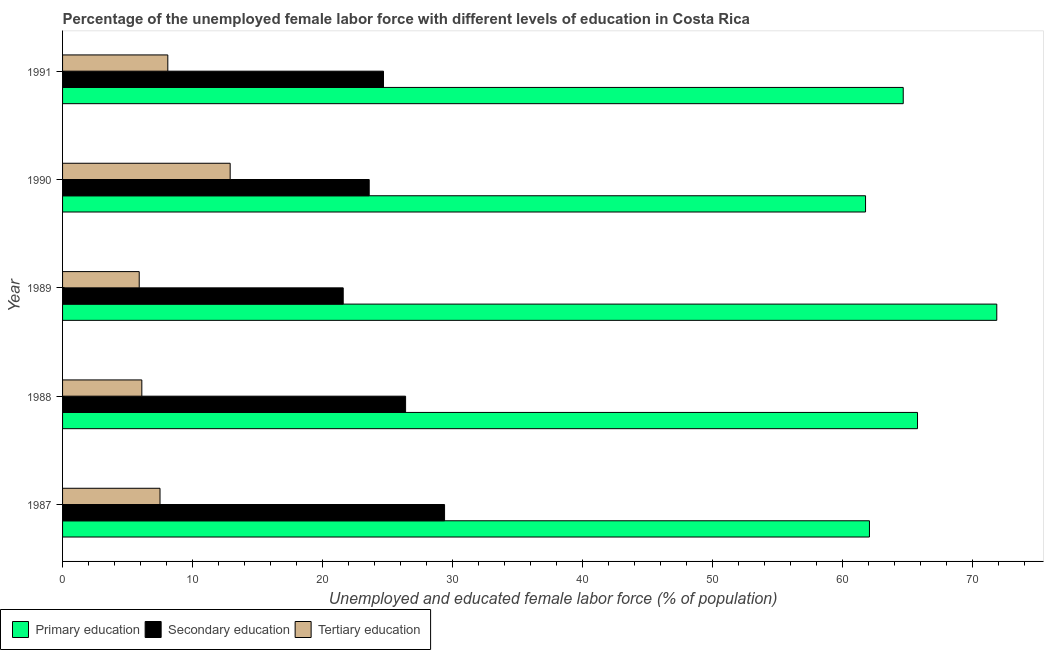Are the number of bars on each tick of the Y-axis equal?
Offer a very short reply. Yes. How many bars are there on the 2nd tick from the top?
Offer a terse response. 3. What is the percentage of female labor force who received tertiary education in 1989?
Provide a short and direct response. 5.9. Across all years, what is the maximum percentage of female labor force who received secondary education?
Your answer should be compact. 29.4. Across all years, what is the minimum percentage of female labor force who received primary education?
Your answer should be very brief. 61.8. In which year was the percentage of female labor force who received secondary education minimum?
Offer a very short reply. 1989. What is the total percentage of female labor force who received primary education in the graph?
Offer a very short reply. 326.3. What is the difference between the percentage of female labor force who received secondary education in 1988 and the percentage of female labor force who received tertiary education in 1990?
Give a very brief answer. 13.5. What is the average percentage of female labor force who received secondary education per year?
Your answer should be very brief. 25.14. In the year 1990, what is the difference between the percentage of female labor force who received primary education and percentage of female labor force who received secondary education?
Give a very brief answer. 38.2. In how many years, is the percentage of female labor force who received tertiary education greater than 66 %?
Your response must be concise. 0. Is the difference between the percentage of female labor force who received primary education in 1990 and 1991 greater than the difference between the percentage of female labor force who received tertiary education in 1990 and 1991?
Provide a short and direct response. No. What is the difference between the highest and the second highest percentage of female labor force who received primary education?
Your answer should be compact. 6.1. In how many years, is the percentage of female labor force who received secondary education greater than the average percentage of female labor force who received secondary education taken over all years?
Your answer should be compact. 2. What does the 1st bar from the top in 1989 represents?
Provide a succinct answer. Tertiary education. What does the 2nd bar from the bottom in 1991 represents?
Keep it short and to the point. Secondary education. Is it the case that in every year, the sum of the percentage of female labor force who received primary education and percentage of female labor force who received secondary education is greater than the percentage of female labor force who received tertiary education?
Keep it short and to the point. Yes. How many bars are there?
Ensure brevity in your answer.  15. What is the difference between two consecutive major ticks on the X-axis?
Make the answer very short. 10. Does the graph contain any zero values?
Keep it short and to the point. No. Does the graph contain grids?
Keep it short and to the point. No. How many legend labels are there?
Give a very brief answer. 3. What is the title of the graph?
Keep it short and to the point. Percentage of the unemployed female labor force with different levels of education in Costa Rica. Does "Methane" appear as one of the legend labels in the graph?
Provide a succinct answer. No. What is the label or title of the X-axis?
Ensure brevity in your answer.  Unemployed and educated female labor force (% of population). What is the label or title of the Y-axis?
Provide a short and direct response. Year. What is the Unemployed and educated female labor force (% of population) of Primary education in 1987?
Keep it short and to the point. 62.1. What is the Unemployed and educated female labor force (% of population) in Secondary education in 1987?
Give a very brief answer. 29.4. What is the Unemployed and educated female labor force (% of population) in Tertiary education in 1987?
Your response must be concise. 7.5. What is the Unemployed and educated female labor force (% of population) of Primary education in 1988?
Ensure brevity in your answer.  65.8. What is the Unemployed and educated female labor force (% of population) of Secondary education in 1988?
Provide a succinct answer. 26.4. What is the Unemployed and educated female labor force (% of population) of Tertiary education in 1988?
Offer a terse response. 6.1. What is the Unemployed and educated female labor force (% of population) in Primary education in 1989?
Your response must be concise. 71.9. What is the Unemployed and educated female labor force (% of population) of Secondary education in 1989?
Give a very brief answer. 21.6. What is the Unemployed and educated female labor force (% of population) of Tertiary education in 1989?
Ensure brevity in your answer.  5.9. What is the Unemployed and educated female labor force (% of population) of Primary education in 1990?
Your answer should be compact. 61.8. What is the Unemployed and educated female labor force (% of population) in Secondary education in 1990?
Your response must be concise. 23.6. What is the Unemployed and educated female labor force (% of population) of Tertiary education in 1990?
Your answer should be very brief. 12.9. What is the Unemployed and educated female labor force (% of population) in Primary education in 1991?
Your answer should be compact. 64.7. What is the Unemployed and educated female labor force (% of population) in Secondary education in 1991?
Your answer should be very brief. 24.7. What is the Unemployed and educated female labor force (% of population) in Tertiary education in 1991?
Your answer should be very brief. 8.1. Across all years, what is the maximum Unemployed and educated female labor force (% of population) in Primary education?
Offer a terse response. 71.9. Across all years, what is the maximum Unemployed and educated female labor force (% of population) in Secondary education?
Your answer should be compact. 29.4. Across all years, what is the maximum Unemployed and educated female labor force (% of population) of Tertiary education?
Make the answer very short. 12.9. Across all years, what is the minimum Unemployed and educated female labor force (% of population) in Primary education?
Keep it short and to the point. 61.8. Across all years, what is the minimum Unemployed and educated female labor force (% of population) of Secondary education?
Give a very brief answer. 21.6. Across all years, what is the minimum Unemployed and educated female labor force (% of population) of Tertiary education?
Your answer should be very brief. 5.9. What is the total Unemployed and educated female labor force (% of population) of Primary education in the graph?
Give a very brief answer. 326.3. What is the total Unemployed and educated female labor force (% of population) of Secondary education in the graph?
Your response must be concise. 125.7. What is the total Unemployed and educated female labor force (% of population) in Tertiary education in the graph?
Ensure brevity in your answer.  40.5. What is the difference between the Unemployed and educated female labor force (% of population) of Secondary education in 1987 and that in 1988?
Make the answer very short. 3. What is the difference between the Unemployed and educated female labor force (% of population) in Tertiary education in 1987 and that in 1988?
Keep it short and to the point. 1.4. What is the difference between the Unemployed and educated female labor force (% of population) of Primary education in 1987 and that in 1989?
Your response must be concise. -9.8. What is the difference between the Unemployed and educated female labor force (% of population) in Tertiary education in 1987 and that in 1989?
Give a very brief answer. 1.6. What is the difference between the Unemployed and educated female labor force (% of population) in Tertiary education in 1987 and that in 1990?
Offer a very short reply. -5.4. What is the difference between the Unemployed and educated female labor force (% of population) of Secondary education in 1987 and that in 1991?
Offer a very short reply. 4.7. What is the difference between the Unemployed and educated female labor force (% of population) of Primary education in 1988 and that in 1989?
Offer a terse response. -6.1. What is the difference between the Unemployed and educated female labor force (% of population) in Primary education in 1988 and that in 1990?
Offer a very short reply. 4. What is the difference between the Unemployed and educated female labor force (% of population) in Secondary education in 1988 and that in 1990?
Your response must be concise. 2.8. What is the difference between the Unemployed and educated female labor force (% of population) in Primary education in 1988 and that in 1991?
Ensure brevity in your answer.  1.1. What is the difference between the Unemployed and educated female labor force (% of population) of Primary education in 1989 and that in 1990?
Offer a terse response. 10.1. What is the difference between the Unemployed and educated female labor force (% of population) in Tertiary education in 1990 and that in 1991?
Give a very brief answer. 4.8. What is the difference between the Unemployed and educated female labor force (% of population) in Primary education in 1987 and the Unemployed and educated female labor force (% of population) in Secondary education in 1988?
Offer a terse response. 35.7. What is the difference between the Unemployed and educated female labor force (% of population) in Secondary education in 1987 and the Unemployed and educated female labor force (% of population) in Tertiary education in 1988?
Your response must be concise. 23.3. What is the difference between the Unemployed and educated female labor force (% of population) in Primary education in 1987 and the Unemployed and educated female labor force (% of population) in Secondary education in 1989?
Provide a short and direct response. 40.5. What is the difference between the Unemployed and educated female labor force (% of population) of Primary education in 1987 and the Unemployed and educated female labor force (% of population) of Tertiary education in 1989?
Ensure brevity in your answer.  56.2. What is the difference between the Unemployed and educated female labor force (% of population) in Secondary education in 1987 and the Unemployed and educated female labor force (% of population) in Tertiary education in 1989?
Your answer should be very brief. 23.5. What is the difference between the Unemployed and educated female labor force (% of population) in Primary education in 1987 and the Unemployed and educated female labor force (% of population) in Secondary education in 1990?
Offer a very short reply. 38.5. What is the difference between the Unemployed and educated female labor force (% of population) of Primary education in 1987 and the Unemployed and educated female labor force (% of population) of Tertiary education in 1990?
Provide a succinct answer. 49.2. What is the difference between the Unemployed and educated female labor force (% of population) in Secondary education in 1987 and the Unemployed and educated female labor force (% of population) in Tertiary education in 1990?
Give a very brief answer. 16.5. What is the difference between the Unemployed and educated female labor force (% of population) in Primary education in 1987 and the Unemployed and educated female labor force (% of population) in Secondary education in 1991?
Make the answer very short. 37.4. What is the difference between the Unemployed and educated female labor force (% of population) of Secondary education in 1987 and the Unemployed and educated female labor force (% of population) of Tertiary education in 1991?
Your answer should be very brief. 21.3. What is the difference between the Unemployed and educated female labor force (% of population) in Primary education in 1988 and the Unemployed and educated female labor force (% of population) in Secondary education in 1989?
Make the answer very short. 44.2. What is the difference between the Unemployed and educated female labor force (% of population) of Primary education in 1988 and the Unemployed and educated female labor force (% of population) of Tertiary education in 1989?
Your answer should be compact. 59.9. What is the difference between the Unemployed and educated female labor force (% of population) of Primary education in 1988 and the Unemployed and educated female labor force (% of population) of Secondary education in 1990?
Your answer should be compact. 42.2. What is the difference between the Unemployed and educated female labor force (% of population) in Primary education in 1988 and the Unemployed and educated female labor force (% of population) in Tertiary education in 1990?
Your answer should be compact. 52.9. What is the difference between the Unemployed and educated female labor force (% of population) in Primary education in 1988 and the Unemployed and educated female labor force (% of population) in Secondary education in 1991?
Make the answer very short. 41.1. What is the difference between the Unemployed and educated female labor force (% of population) in Primary education in 1988 and the Unemployed and educated female labor force (% of population) in Tertiary education in 1991?
Offer a terse response. 57.7. What is the difference between the Unemployed and educated female labor force (% of population) in Secondary education in 1988 and the Unemployed and educated female labor force (% of population) in Tertiary education in 1991?
Your answer should be compact. 18.3. What is the difference between the Unemployed and educated female labor force (% of population) of Primary education in 1989 and the Unemployed and educated female labor force (% of population) of Secondary education in 1990?
Your answer should be very brief. 48.3. What is the difference between the Unemployed and educated female labor force (% of population) in Primary education in 1989 and the Unemployed and educated female labor force (% of population) in Tertiary education in 1990?
Keep it short and to the point. 59. What is the difference between the Unemployed and educated female labor force (% of population) in Secondary education in 1989 and the Unemployed and educated female labor force (% of population) in Tertiary education in 1990?
Ensure brevity in your answer.  8.7. What is the difference between the Unemployed and educated female labor force (% of population) of Primary education in 1989 and the Unemployed and educated female labor force (% of population) of Secondary education in 1991?
Offer a terse response. 47.2. What is the difference between the Unemployed and educated female labor force (% of population) in Primary education in 1989 and the Unemployed and educated female labor force (% of population) in Tertiary education in 1991?
Provide a succinct answer. 63.8. What is the difference between the Unemployed and educated female labor force (% of population) in Secondary education in 1989 and the Unemployed and educated female labor force (% of population) in Tertiary education in 1991?
Offer a very short reply. 13.5. What is the difference between the Unemployed and educated female labor force (% of population) in Primary education in 1990 and the Unemployed and educated female labor force (% of population) in Secondary education in 1991?
Give a very brief answer. 37.1. What is the difference between the Unemployed and educated female labor force (% of population) in Primary education in 1990 and the Unemployed and educated female labor force (% of population) in Tertiary education in 1991?
Keep it short and to the point. 53.7. What is the average Unemployed and educated female labor force (% of population) in Primary education per year?
Offer a terse response. 65.26. What is the average Unemployed and educated female labor force (% of population) of Secondary education per year?
Make the answer very short. 25.14. What is the average Unemployed and educated female labor force (% of population) in Tertiary education per year?
Offer a very short reply. 8.1. In the year 1987, what is the difference between the Unemployed and educated female labor force (% of population) of Primary education and Unemployed and educated female labor force (% of population) of Secondary education?
Provide a short and direct response. 32.7. In the year 1987, what is the difference between the Unemployed and educated female labor force (% of population) in Primary education and Unemployed and educated female labor force (% of population) in Tertiary education?
Provide a succinct answer. 54.6. In the year 1987, what is the difference between the Unemployed and educated female labor force (% of population) of Secondary education and Unemployed and educated female labor force (% of population) of Tertiary education?
Your response must be concise. 21.9. In the year 1988, what is the difference between the Unemployed and educated female labor force (% of population) in Primary education and Unemployed and educated female labor force (% of population) in Secondary education?
Give a very brief answer. 39.4. In the year 1988, what is the difference between the Unemployed and educated female labor force (% of population) of Primary education and Unemployed and educated female labor force (% of population) of Tertiary education?
Give a very brief answer. 59.7. In the year 1988, what is the difference between the Unemployed and educated female labor force (% of population) of Secondary education and Unemployed and educated female labor force (% of population) of Tertiary education?
Ensure brevity in your answer.  20.3. In the year 1989, what is the difference between the Unemployed and educated female labor force (% of population) of Primary education and Unemployed and educated female labor force (% of population) of Secondary education?
Provide a succinct answer. 50.3. In the year 1990, what is the difference between the Unemployed and educated female labor force (% of population) in Primary education and Unemployed and educated female labor force (% of population) in Secondary education?
Provide a short and direct response. 38.2. In the year 1990, what is the difference between the Unemployed and educated female labor force (% of population) of Primary education and Unemployed and educated female labor force (% of population) of Tertiary education?
Your response must be concise. 48.9. In the year 1990, what is the difference between the Unemployed and educated female labor force (% of population) in Secondary education and Unemployed and educated female labor force (% of population) in Tertiary education?
Your answer should be very brief. 10.7. In the year 1991, what is the difference between the Unemployed and educated female labor force (% of population) in Primary education and Unemployed and educated female labor force (% of population) in Tertiary education?
Your response must be concise. 56.6. In the year 1991, what is the difference between the Unemployed and educated female labor force (% of population) in Secondary education and Unemployed and educated female labor force (% of population) in Tertiary education?
Make the answer very short. 16.6. What is the ratio of the Unemployed and educated female labor force (% of population) in Primary education in 1987 to that in 1988?
Offer a very short reply. 0.94. What is the ratio of the Unemployed and educated female labor force (% of population) of Secondary education in 1987 to that in 1988?
Ensure brevity in your answer.  1.11. What is the ratio of the Unemployed and educated female labor force (% of population) of Tertiary education in 1987 to that in 1988?
Offer a terse response. 1.23. What is the ratio of the Unemployed and educated female labor force (% of population) of Primary education in 1987 to that in 1989?
Provide a succinct answer. 0.86. What is the ratio of the Unemployed and educated female labor force (% of population) of Secondary education in 1987 to that in 1989?
Your response must be concise. 1.36. What is the ratio of the Unemployed and educated female labor force (% of population) in Tertiary education in 1987 to that in 1989?
Give a very brief answer. 1.27. What is the ratio of the Unemployed and educated female labor force (% of population) of Primary education in 1987 to that in 1990?
Provide a short and direct response. 1. What is the ratio of the Unemployed and educated female labor force (% of population) of Secondary education in 1987 to that in 1990?
Keep it short and to the point. 1.25. What is the ratio of the Unemployed and educated female labor force (% of population) of Tertiary education in 1987 to that in 1990?
Provide a short and direct response. 0.58. What is the ratio of the Unemployed and educated female labor force (% of population) of Primary education in 1987 to that in 1991?
Offer a terse response. 0.96. What is the ratio of the Unemployed and educated female labor force (% of population) in Secondary education in 1987 to that in 1991?
Your answer should be compact. 1.19. What is the ratio of the Unemployed and educated female labor force (% of population) in Tertiary education in 1987 to that in 1991?
Your response must be concise. 0.93. What is the ratio of the Unemployed and educated female labor force (% of population) of Primary education in 1988 to that in 1989?
Your answer should be very brief. 0.92. What is the ratio of the Unemployed and educated female labor force (% of population) of Secondary education in 1988 to that in 1989?
Make the answer very short. 1.22. What is the ratio of the Unemployed and educated female labor force (% of population) in Tertiary education in 1988 to that in 1989?
Offer a terse response. 1.03. What is the ratio of the Unemployed and educated female labor force (% of population) of Primary education in 1988 to that in 1990?
Make the answer very short. 1.06. What is the ratio of the Unemployed and educated female labor force (% of population) in Secondary education in 1988 to that in 1990?
Provide a succinct answer. 1.12. What is the ratio of the Unemployed and educated female labor force (% of population) of Tertiary education in 1988 to that in 1990?
Your response must be concise. 0.47. What is the ratio of the Unemployed and educated female labor force (% of population) of Primary education in 1988 to that in 1991?
Ensure brevity in your answer.  1.02. What is the ratio of the Unemployed and educated female labor force (% of population) of Secondary education in 1988 to that in 1991?
Provide a short and direct response. 1.07. What is the ratio of the Unemployed and educated female labor force (% of population) of Tertiary education in 1988 to that in 1991?
Give a very brief answer. 0.75. What is the ratio of the Unemployed and educated female labor force (% of population) in Primary education in 1989 to that in 1990?
Offer a terse response. 1.16. What is the ratio of the Unemployed and educated female labor force (% of population) of Secondary education in 1989 to that in 1990?
Ensure brevity in your answer.  0.92. What is the ratio of the Unemployed and educated female labor force (% of population) of Tertiary education in 1989 to that in 1990?
Offer a terse response. 0.46. What is the ratio of the Unemployed and educated female labor force (% of population) of Primary education in 1989 to that in 1991?
Provide a short and direct response. 1.11. What is the ratio of the Unemployed and educated female labor force (% of population) in Secondary education in 1989 to that in 1991?
Give a very brief answer. 0.87. What is the ratio of the Unemployed and educated female labor force (% of population) of Tertiary education in 1989 to that in 1991?
Make the answer very short. 0.73. What is the ratio of the Unemployed and educated female labor force (% of population) in Primary education in 1990 to that in 1991?
Your response must be concise. 0.96. What is the ratio of the Unemployed and educated female labor force (% of population) in Secondary education in 1990 to that in 1991?
Give a very brief answer. 0.96. What is the ratio of the Unemployed and educated female labor force (% of population) of Tertiary education in 1990 to that in 1991?
Make the answer very short. 1.59. What is the difference between the highest and the lowest Unemployed and educated female labor force (% of population) in Tertiary education?
Your answer should be very brief. 7. 